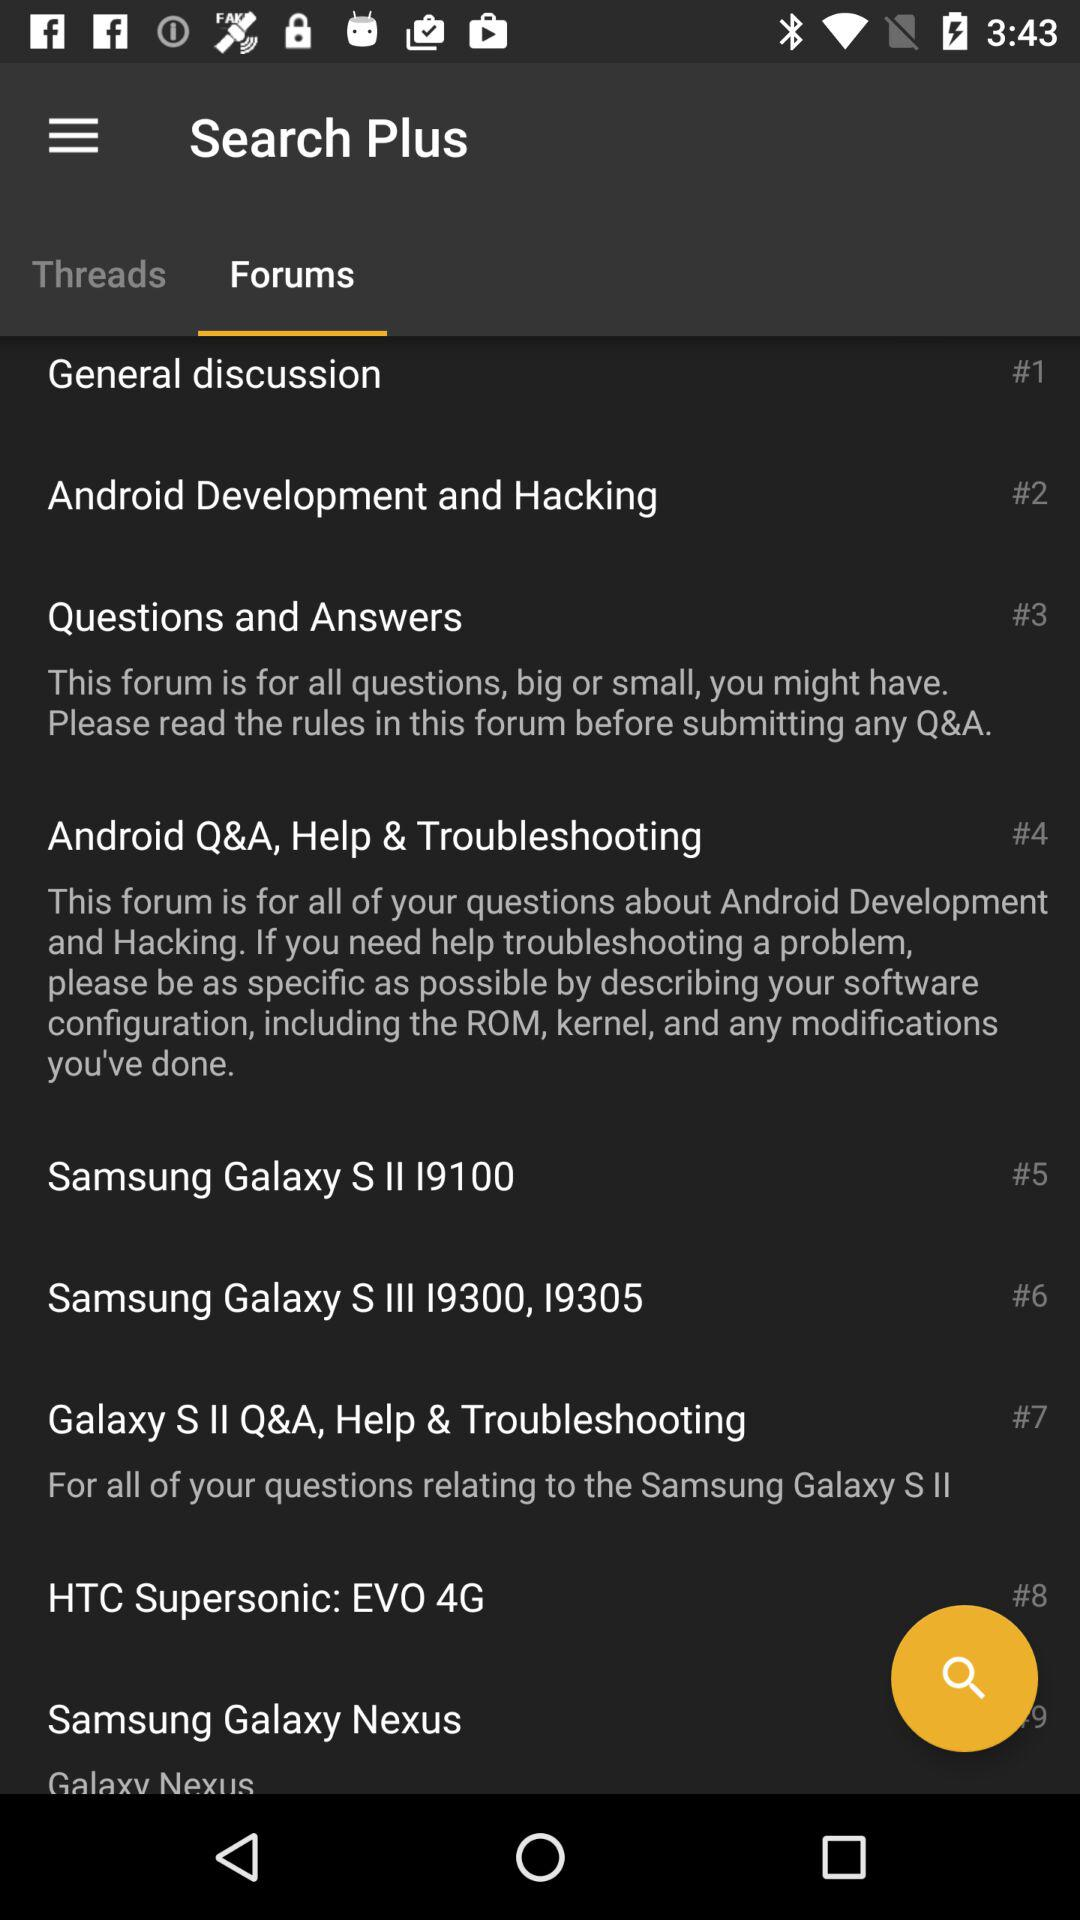How many forums are there?
Answer the question using a single word or phrase. 9 